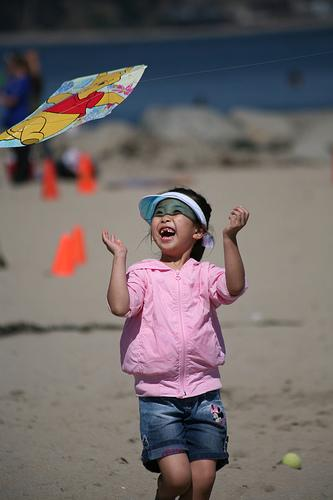Describe the appearance of the girl in the image. The girl has missing front teeth, a white sun visor, a pink zip-up jacket, and blue jean shorts featuring a Minnie Mouse character. Provide a brief description of the scene in the image. A happy little girl on the beach is looking up at a Winnie the Pooh kite, wearing a pink jacket, jean shorts, and a white sun visor. Mention the location and activity of the girl in the image. The little girl is standing on a sandy beach near a lake, looking up at a kite flying above her. Describe the accessories and details on the girl's outfit. The girl is wearing a white sun visor, a pink zip-up jacket with a central zipper, and jean shorts with a Minnie Mouse design near the pocket. Provide a concise summary of the objects surrounding the girl in the image. The girl is surrounded by a Winnie the Pooh kite, a tennis ball, and orange cones on the sandy beach with water in the background. Mention the most eye-catching elements in the image. A girl on the sand smiles at a colorful kite featuring Winnie the Pooh, with a tennis ball and orange cones nearby. Discuss the visual elements connected to the beach and water in the image. The image features a sandy beach with a blue lake in the background, a green tennis ball, and orange cones on the ground near the girl. Focus on the various Disney characters present in the image. The image shows Winnie the Pooh and a red-shirted bear on a kite and a smiling Minnie Mouse character near the girl's shorts pocket. Describe the kite and its position in the image. A Winnie the Pooh kite with a red-shirted bear character is flying high in the sky above the girl's head, with its string extending down. 